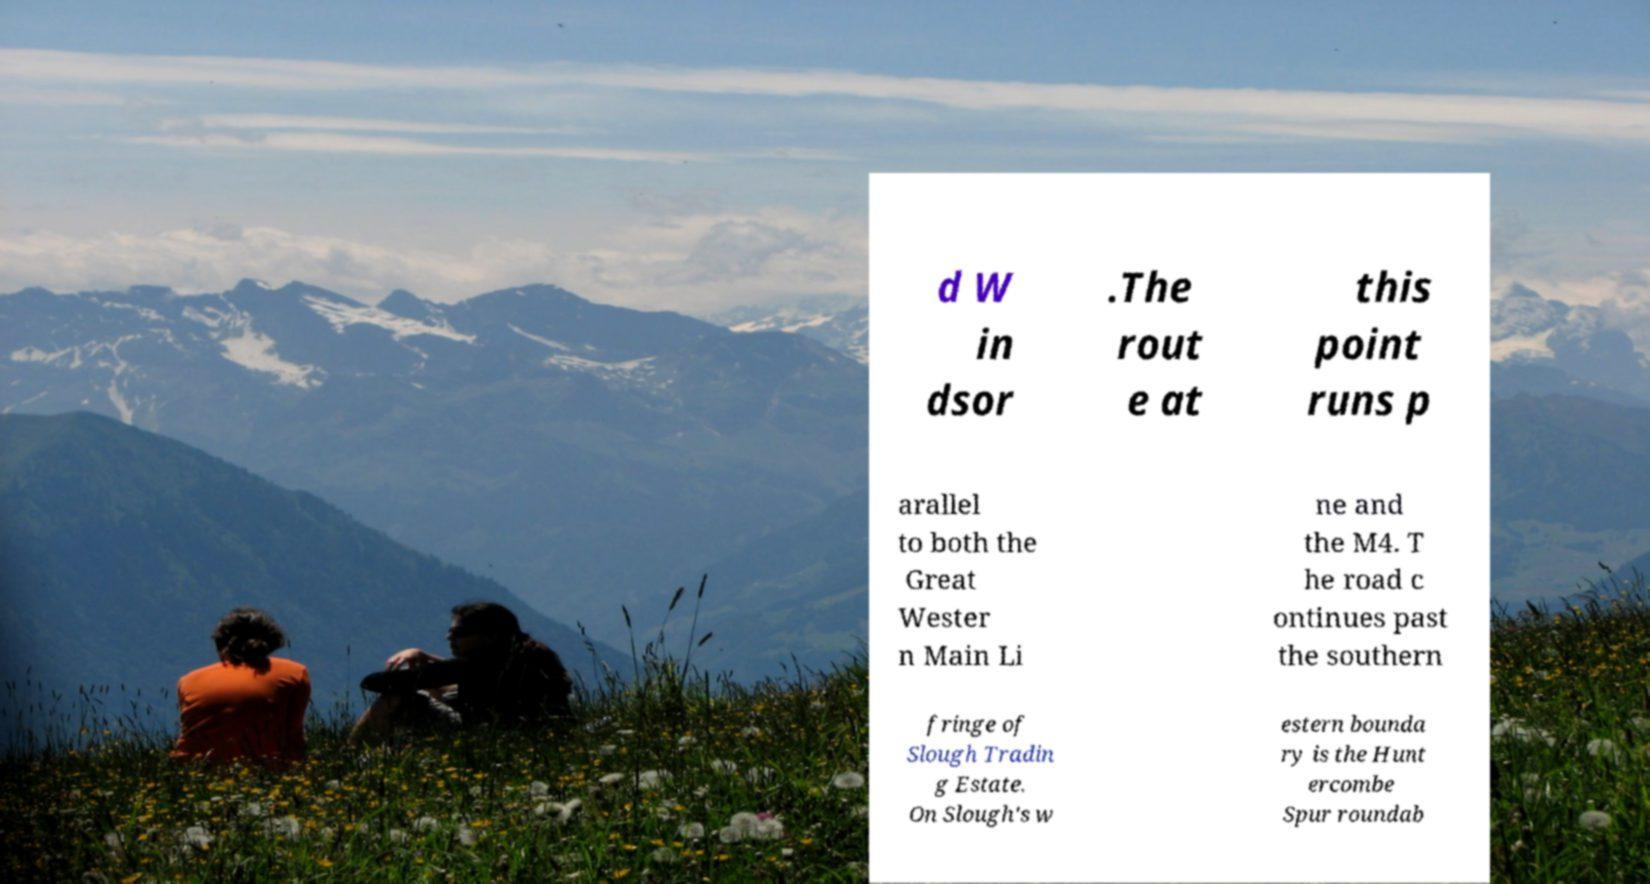For documentation purposes, I need the text within this image transcribed. Could you provide that? d W in dsor .The rout e at this point runs p arallel to both the Great Wester n Main Li ne and the M4. T he road c ontinues past the southern fringe of Slough Tradin g Estate. On Slough's w estern bounda ry is the Hunt ercombe Spur roundab 